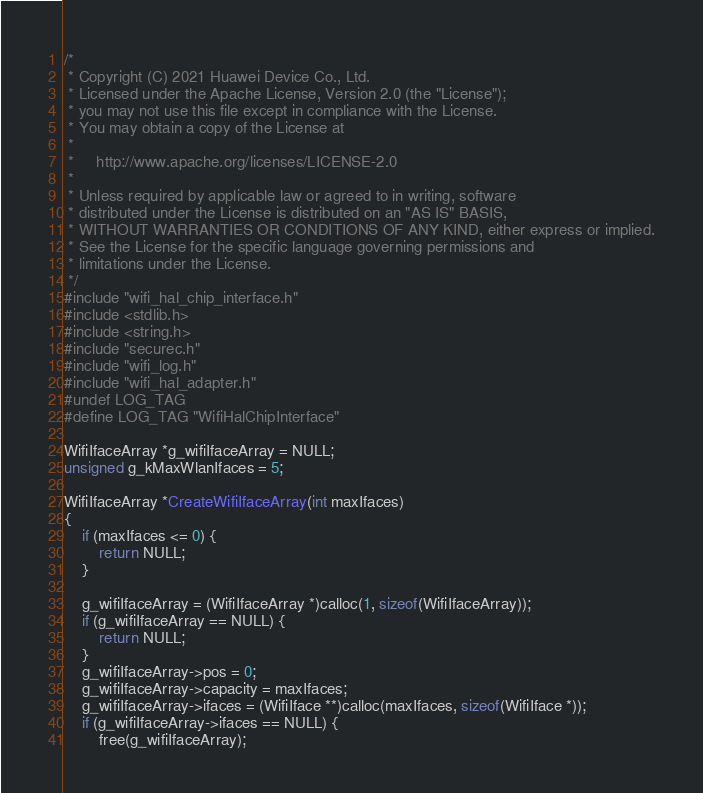Convert code to text. <code><loc_0><loc_0><loc_500><loc_500><_C_>/*
 * Copyright (C) 2021 Huawei Device Co., Ltd.
 * Licensed under the Apache License, Version 2.0 (the "License");
 * you may not use this file except in compliance with the License.
 * You may obtain a copy of the License at
 *
 *     http://www.apache.org/licenses/LICENSE-2.0
 *
 * Unless required by applicable law or agreed to in writing, software
 * distributed under the License is distributed on an "AS IS" BASIS,
 * WITHOUT WARRANTIES OR CONDITIONS OF ANY KIND, either express or implied.
 * See the License for the specific language governing permissions and
 * limitations under the License.
 */
#include "wifi_hal_chip_interface.h"
#include <stdlib.h>
#include <string.h>
#include "securec.h"
#include "wifi_log.h"
#include "wifi_hal_adapter.h"
#undef LOG_TAG
#define LOG_TAG "WifiHalChipInterface"

WifiIfaceArray *g_wifiIfaceArray = NULL;
unsigned g_kMaxWlanIfaces = 5;

WifiIfaceArray *CreateWifiIfaceArray(int maxIfaces)
{
    if (maxIfaces <= 0) {
        return NULL;
    }

    g_wifiIfaceArray = (WifiIfaceArray *)calloc(1, sizeof(WifiIfaceArray));
    if (g_wifiIfaceArray == NULL) {
        return NULL;
    }
    g_wifiIfaceArray->pos = 0;
    g_wifiIfaceArray->capacity = maxIfaces;
    g_wifiIfaceArray->ifaces = (WifiIface **)calloc(maxIfaces, sizeof(WifiIface *));
    if (g_wifiIfaceArray->ifaces == NULL) {
        free(g_wifiIfaceArray);</code> 